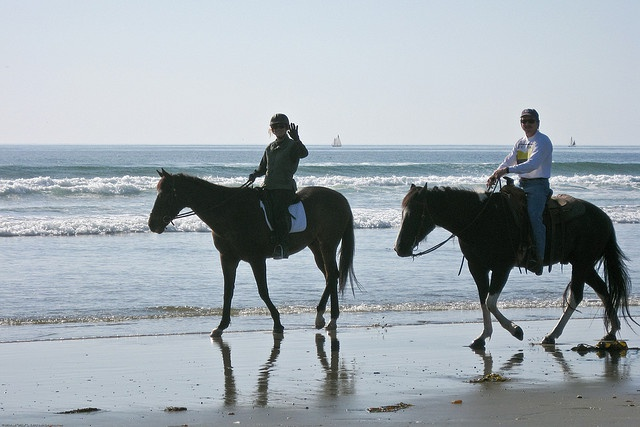Describe the objects in this image and their specific colors. I can see horse in lightgray, black, gray, and darkgray tones, horse in lightgray, black, gray, darkgray, and purple tones, people in lightgray, black, gray, and darkgray tones, people in lightgray, black, gray, and darkblue tones, and boat in lightgray, darkgray, and gray tones in this image. 